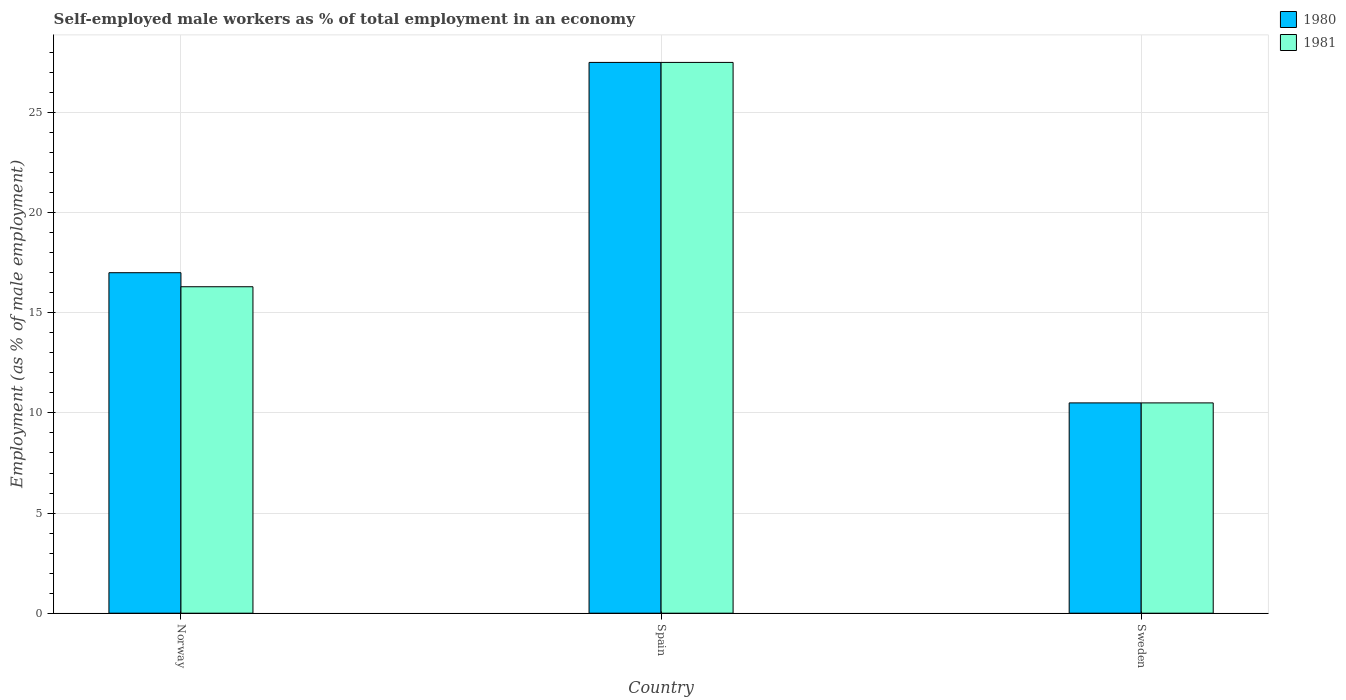How many groups of bars are there?
Offer a terse response. 3. How many bars are there on the 1st tick from the left?
Provide a short and direct response. 2. How many bars are there on the 1st tick from the right?
Give a very brief answer. 2. What is the label of the 3rd group of bars from the left?
Keep it short and to the point. Sweden. In how many cases, is the number of bars for a given country not equal to the number of legend labels?
Keep it short and to the point. 0. What is the percentage of self-employed male workers in 1981 in Spain?
Give a very brief answer. 27.5. Across all countries, what is the maximum percentage of self-employed male workers in 1981?
Keep it short and to the point. 27.5. Across all countries, what is the minimum percentage of self-employed male workers in 1980?
Ensure brevity in your answer.  10.5. In which country was the percentage of self-employed male workers in 1981 maximum?
Your response must be concise. Spain. What is the total percentage of self-employed male workers in 1981 in the graph?
Ensure brevity in your answer.  54.3. What is the difference between the percentage of self-employed male workers in 1980 in Sweden and the percentage of self-employed male workers in 1981 in Spain?
Your answer should be compact. -17. What is the average percentage of self-employed male workers in 1980 per country?
Your response must be concise. 18.33. What is the ratio of the percentage of self-employed male workers in 1981 in Spain to that in Sweden?
Your response must be concise. 2.62. Is the difference between the percentage of self-employed male workers in 1981 in Norway and Spain greater than the difference between the percentage of self-employed male workers in 1980 in Norway and Spain?
Offer a very short reply. No. What is the difference between the highest and the lowest percentage of self-employed male workers in 1981?
Your answer should be compact. 17. What does the 1st bar from the left in Spain represents?
Ensure brevity in your answer.  1980. How many bars are there?
Your answer should be compact. 6. Are all the bars in the graph horizontal?
Offer a very short reply. No. How many countries are there in the graph?
Provide a succinct answer. 3. Does the graph contain any zero values?
Provide a succinct answer. No. Does the graph contain grids?
Provide a succinct answer. Yes. Where does the legend appear in the graph?
Provide a succinct answer. Top right. How many legend labels are there?
Make the answer very short. 2. How are the legend labels stacked?
Make the answer very short. Vertical. What is the title of the graph?
Ensure brevity in your answer.  Self-employed male workers as % of total employment in an economy. What is the label or title of the X-axis?
Keep it short and to the point. Country. What is the label or title of the Y-axis?
Provide a short and direct response. Employment (as % of male employment). What is the Employment (as % of male employment) in 1981 in Norway?
Your answer should be very brief. 16.3. Across all countries, what is the maximum Employment (as % of male employment) in 1981?
Provide a short and direct response. 27.5. What is the total Employment (as % of male employment) of 1981 in the graph?
Provide a succinct answer. 54.3. What is the difference between the Employment (as % of male employment) in 1980 in Norway and that in Spain?
Your answer should be compact. -10.5. What is the difference between the Employment (as % of male employment) in 1981 in Norway and that in Sweden?
Your answer should be very brief. 5.8. What is the difference between the Employment (as % of male employment) in 1980 in Norway and the Employment (as % of male employment) in 1981 in Spain?
Make the answer very short. -10.5. What is the average Employment (as % of male employment) of 1980 per country?
Provide a short and direct response. 18.33. What is the difference between the Employment (as % of male employment) of 1980 and Employment (as % of male employment) of 1981 in Norway?
Keep it short and to the point. 0.7. What is the difference between the Employment (as % of male employment) of 1980 and Employment (as % of male employment) of 1981 in Spain?
Offer a terse response. 0. What is the difference between the Employment (as % of male employment) in 1980 and Employment (as % of male employment) in 1981 in Sweden?
Provide a succinct answer. 0. What is the ratio of the Employment (as % of male employment) in 1980 in Norway to that in Spain?
Your answer should be very brief. 0.62. What is the ratio of the Employment (as % of male employment) in 1981 in Norway to that in Spain?
Provide a succinct answer. 0.59. What is the ratio of the Employment (as % of male employment) of 1980 in Norway to that in Sweden?
Offer a very short reply. 1.62. What is the ratio of the Employment (as % of male employment) of 1981 in Norway to that in Sweden?
Offer a terse response. 1.55. What is the ratio of the Employment (as % of male employment) in 1980 in Spain to that in Sweden?
Make the answer very short. 2.62. What is the ratio of the Employment (as % of male employment) in 1981 in Spain to that in Sweden?
Your answer should be very brief. 2.62. What is the difference between the highest and the second highest Employment (as % of male employment) of 1980?
Provide a short and direct response. 10.5. What is the difference between the highest and the lowest Employment (as % of male employment) in 1980?
Provide a short and direct response. 17. 